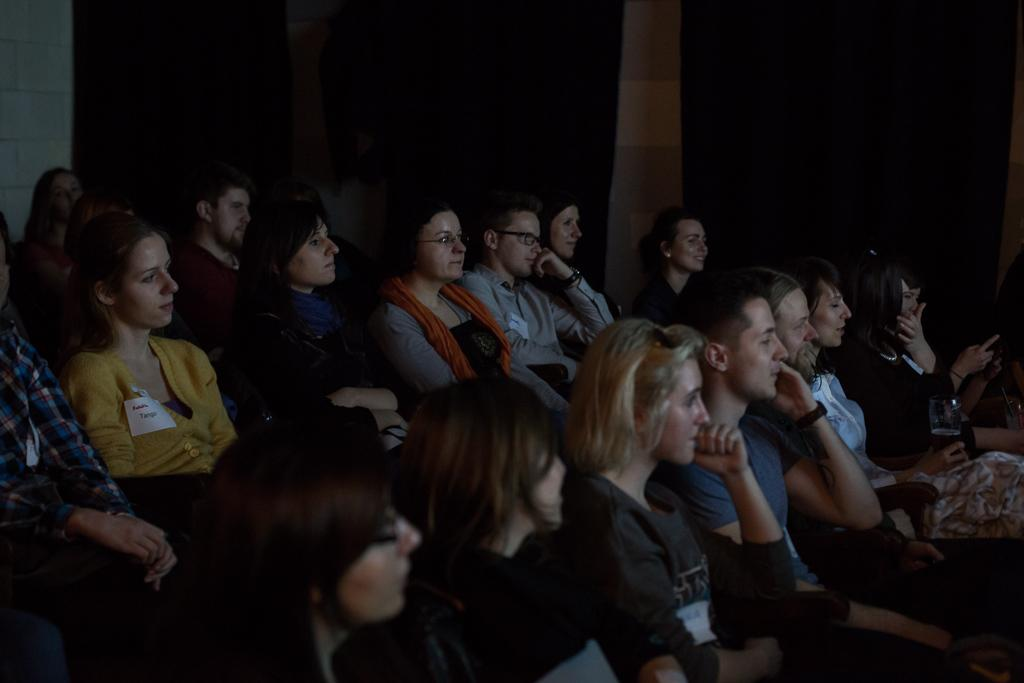What are the persons in the image doing? The persons in the image are sitting on chairs. Are the persons sitting alone or together? The persons are sitting together. What can be seen hanging around the necks of the persons in the image? The persons are wearing ID cards. How many mice can be seen running around the persons' feet in the image? There are no mice present in the image. What type of wrist accessory is visible on the persons in the image? There is no specific wrist accessory mentioned in the facts provided, as the focus is on the persons sitting together and wearing ID cards. 